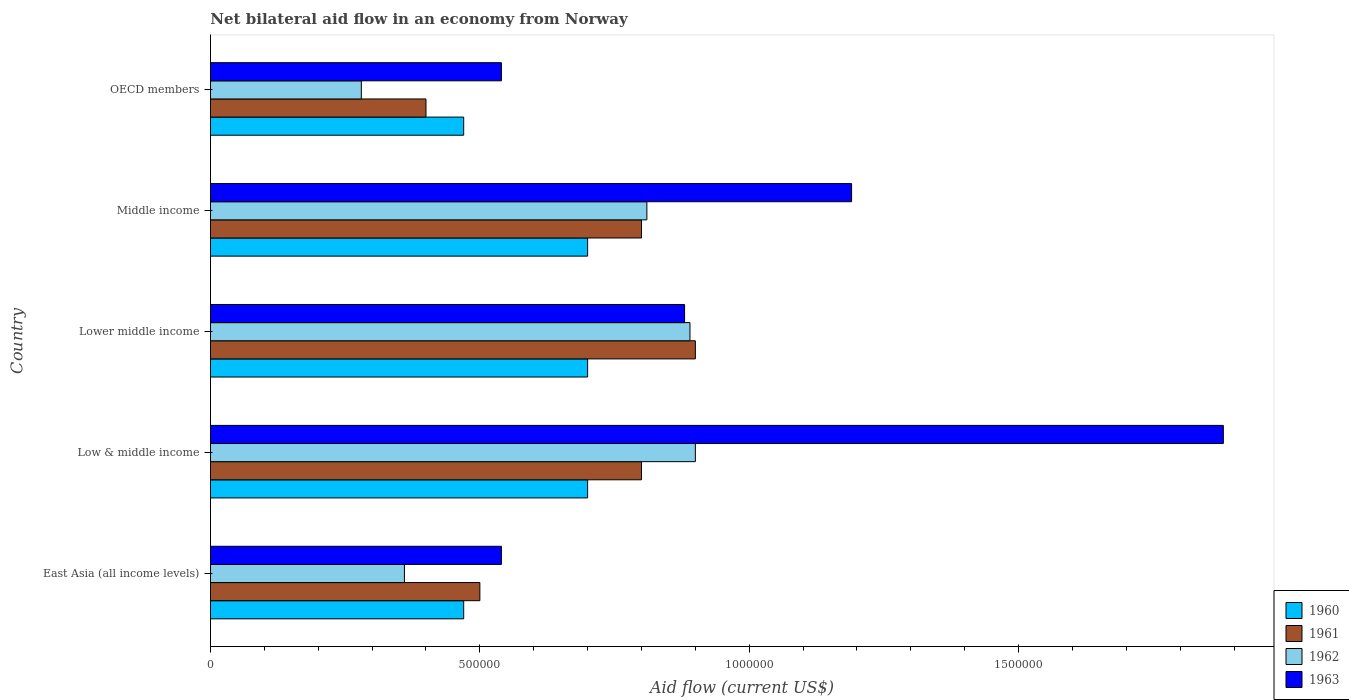How many different coloured bars are there?
Provide a short and direct response. 4. How many groups of bars are there?
Ensure brevity in your answer.  5. Are the number of bars on each tick of the Y-axis equal?
Your response must be concise. Yes. How many bars are there on the 3rd tick from the bottom?
Your answer should be compact. 4. What is the label of the 5th group of bars from the top?
Your response must be concise. East Asia (all income levels). What is the net bilateral aid flow in 1960 in Lower middle income?
Provide a short and direct response. 7.00e+05. Across all countries, what is the minimum net bilateral aid flow in 1962?
Keep it short and to the point. 2.80e+05. In which country was the net bilateral aid flow in 1961 maximum?
Give a very brief answer. Lower middle income. In which country was the net bilateral aid flow in 1963 minimum?
Offer a very short reply. East Asia (all income levels). What is the total net bilateral aid flow in 1960 in the graph?
Offer a terse response. 3.04e+06. What is the difference between the net bilateral aid flow in 1963 in Low & middle income and that in Middle income?
Your answer should be compact. 6.90e+05. What is the difference between the net bilateral aid flow in 1963 in OECD members and the net bilateral aid flow in 1960 in Lower middle income?
Keep it short and to the point. -1.60e+05. What is the average net bilateral aid flow in 1960 per country?
Give a very brief answer. 6.08e+05. What is the difference between the highest and the lowest net bilateral aid flow in 1962?
Your answer should be very brief. 6.20e+05. Is the sum of the net bilateral aid flow in 1962 in Middle income and OECD members greater than the maximum net bilateral aid flow in 1963 across all countries?
Provide a short and direct response. No. What does the 1st bar from the top in Lower middle income represents?
Offer a very short reply. 1963. What does the 3rd bar from the bottom in OECD members represents?
Make the answer very short. 1962. How many bars are there?
Your response must be concise. 20. Are all the bars in the graph horizontal?
Provide a succinct answer. Yes. Are the values on the major ticks of X-axis written in scientific E-notation?
Offer a terse response. No. Does the graph contain any zero values?
Keep it short and to the point. No. Does the graph contain grids?
Ensure brevity in your answer.  No. Where does the legend appear in the graph?
Your answer should be compact. Bottom right. How many legend labels are there?
Your answer should be compact. 4. How are the legend labels stacked?
Make the answer very short. Vertical. What is the title of the graph?
Your response must be concise. Net bilateral aid flow in an economy from Norway. Does "1962" appear as one of the legend labels in the graph?
Ensure brevity in your answer.  Yes. What is the Aid flow (current US$) in 1963 in East Asia (all income levels)?
Keep it short and to the point. 5.40e+05. What is the Aid flow (current US$) of 1960 in Low & middle income?
Offer a terse response. 7.00e+05. What is the Aid flow (current US$) in 1961 in Low & middle income?
Your response must be concise. 8.00e+05. What is the Aid flow (current US$) in 1963 in Low & middle income?
Provide a short and direct response. 1.88e+06. What is the Aid flow (current US$) of 1960 in Lower middle income?
Provide a succinct answer. 7.00e+05. What is the Aid flow (current US$) in 1962 in Lower middle income?
Offer a terse response. 8.90e+05. What is the Aid flow (current US$) of 1963 in Lower middle income?
Provide a succinct answer. 8.80e+05. What is the Aid flow (current US$) in 1962 in Middle income?
Your answer should be compact. 8.10e+05. What is the Aid flow (current US$) in 1963 in Middle income?
Offer a very short reply. 1.19e+06. What is the Aid flow (current US$) in 1961 in OECD members?
Make the answer very short. 4.00e+05. What is the Aid flow (current US$) of 1963 in OECD members?
Your response must be concise. 5.40e+05. Across all countries, what is the maximum Aid flow (current US$) in 1961?
Offer a terse response. 9.00e+05. Across all countries, what is the maximum Aid flow (current US$) in 1963?
Your answer should be very brief. 1.88e+06. Across all countries, what is the minimum Aid flow (current US$) in 1960?
Your answer should be compact. 4.70e+05. Across all countries, what is the minimum Aid flow (current US$) of 1962?
Offer a very short reply. 2.80e+05. Across all countries, what is the minimum Aid flow (current US$) of 1963?
Your answer should be compact. 5.40e+05. What is the total Aid flow (current US$) of 1960 in the graph?
Give a very brief answer. 3.04e+06. What is the total Aid flow (current US$) of 1961 in the graph?
Your response must be concise. 3.40e+06. What is the total Aid flow (current US$) of 1962 in the graph?
Keep it short and to the point. 3.24e+06. What is the total Aid flow (current US$) in 1963 in the graph?
Provide a short and direct response. 5.03e+06. What is the difference between the Aid flow (current US$) in 1960 in East Asia (all income levels) and that in Low & middle income?
Your answer should be very brief. -2.30e+05. What is the difference between the Aid flow (current US$) of 1962 in East Asia (all income levels) and that in Low & middle income?
Offer a terse response. -5.40e+05. What is the difference between the Aid flow (current US$) of 1963 in East Asia (all income levels) and that in Low & middle income?
Offer a terse response. -1.34e+06. What is the difference between the Aid flow (current US$) of 1960 in East Asia (all income levels) and that in Lower middle income?
Ensure brevity in your answer.  -2.30e+05. What is the difference between the Aid flow (current US$) of 1961 in East Asia (all income levels) and that in Lower middle income?
Keep it short and to the point. -4.00e+05. What is the difference between the Aid flow (current US$) in 1962 in East Asia (all income levels) and that in Lower middle income?
Give a very brief answer. -5.30e+05. What is the difference between the Aid flow (current US$) of 1961 in East Asia (all income levels) and that in Middle income?
Your answer should be very brief. -3.00e+05. What is the difference between the Aid flow (current US$) in 1962 in East Asia (all income levels) and that in Middle income?
Your answer should be very brief. -4.50e+05. What is the difference between the Aid flow (current US$) of 1963 in East Asia (all income levels) and that in Middle income?
Your answer should be very brief. -6.50e+05. What is the difference between the Aid flow (current US$) of 1960 in East Asia (all income levels) and that in OECD members?
Give a very brief answer. 0. What is the difference between the Aid flow (current US$) of 1963 in East Asia (all income levels) and that in OECD members?
Provide a short and direct response. 0. What is the difference between the Aid flow (current US$) in 1963 in Low & middle income and that in Lower middle income?
Offer a terse response. 1.00e+06. What is the difference between the Aid flow (current US$) in 1960 in Low & middle income and that in Middle income?
Ensure brevity in your answer.  0. What is the difference between the Aid flow (current US$) of 1961 in Low & middle income and that in Middle income?
Offer a very short reply. 0. What is the difference between the Aid flow (current US$) in 1962 in Low & middle income and that in Middle income?
Ensure brevity in your answer.  9.00e+04. What is the difference between the Aid flow (current US$) in 1963 in Low & middle income and that in Middle income?
Ensure brevity in your answer.  6.90e+05. What is the difference between the Aid flow (current US$) in 1960 in Low & middle income and that in OECD members?
Offer a terse response. 2.30e+05. What is the difference between the Aid flow (current US$) of 1961 in Low & middle income and that in OECD members?
Your response must be concise. 4.00e+05. What is the difference between the Aid flow (current US$) of 1962 in Low & middle income and that in OECD members?
Make the answer very short. 6.20e+05. What is the difference between the Aid flow (current US$) in 1963 in Low & middle income and that in OECD members?
Offer a very short reply. 1.34e+06. What is the difference between the Aid flow (current US$) in 1960 in Lower middle income and that in Middle income?
Your answer should be compact. 0. What is the difference between the Aid flow (current US$) of 1962 in Lower middle income and that in Middle income?
Your response must be concise. 8.00e+04. What is the difference between the Aid flow (current US$) in 1963 in Lower middle income and that in Middle income?
Make the answer very short. -3.10e+05. What is the difference between the Aid flow (current US$) of 1960 in Middle income and that in OECD members?
Make the answer very short. 2.30e+05. What is the difference between the Aid flow (current US$) in 1962 in Middle income and that in OECD members?
Your answer should be compact. 5.30e+05. What is the difference between the Aid flow (current US$) in 1963 in Middle income and that in OECD members?
Offer a very short reply. 6.50e+05. What is the difference between the Aid flow (current US$) of 1960 in East Asia (all income levels) and the Aid flow (current US$) of 1961 in Low & middle income?
Your answer should be very brief. -3.30e+05. What is the difference between the Aid flow (current US$) of 1960 in East Asia (all income levels) and the Aid flow (current US$) of 1962 in Low & middle income?
Your answer should be very brief. -4.30e+05. What is the difference between the Aid flow (current US$) of 1960 in East Asia (all income levels) and the Aid flow (current US$) of 1963 in Low & middle income?
Keep it short and to the point. -1.41e+06. What is the difference between the Aid flow (current US$) in 1961 in East Asia (all income levels) and the Aid flow (current US$) in 1962 in Low & middle income?
Keep it short and to the point. -4.00e+05. What is the difference between the Aid flow (current US$) in 1961 in East Asia (all income levels) and the Aid flow (current US$) in 1963 in Low & middle income?
Provide a succinct answer. -1.38e+06. What is the difference between the Aid flow (current US$) in 1962 in East Asia (all income levels) and the Aid flow (current US$) in 1963 in Low & middle income?
Give a very brief answer. -1.52e+06. What is the difference between the Aid flow (current US$) of 1960 in East Asia (all income levels) and the Aid flow (current US$) of 1961 in Lower middle income?
Give a very brief answer. -4.30e+05. What is the difference between the Aid flow (current US$) in 1960 in East Asia (all income levels) and the Aid flow (current US$) in 1962 in Lower middle income?
Ensure brevity in your answer.  -4.20e+05. What is the difference between the Aid flow (current US$) of 1960 in East Asia (all income levels) and the Aid flow (current US$) of 1963 in Lower middle income?
Provide a succinct answer. -4.10e+05. What is the difference between the Aid flow (current US$) in 1961 in East Asia (all income levels) and the Aid flow (current US$) in 1962 in Lower middle income?
Provide a succinct answer. -3.90e+05. What is the difference between the Aid flow (current US$) of 1961 in East Asia (all income levels) and the Aid flow (current US$) of 1963 in Lower middle income?
Give a very brief answer. -3.80e+05. What is the difference between the Aid flow (current US$) of 1962 in East Asia (all income levels) and the Aid flow (current US$) of 1963 in Lower middle income?
Provide a short and direct response. -5.20e+05. What is the difference between the Aid flow (current US$) of 1960 in East Asia (all income levels) and the Aid flow (current US$) of 1961 in Middle income?
Provide a succinct answer. -3.30e+05. What is the difference between the Aid flow (current US$) of 1960 in East Asia (all income levels) and the Aid flow (current US$) of 1963 in Middle income?
Your answer should be very brief. -7.20e+05. What is the difference between the Aid flow (current US$) in 1961 in East Asia (all income levels) and the Aid flow (current US$) in 1962 in Middle income?
Your response must be concise. -3.10e+05. What is the difference between the Aid flow (current US$) of 1961 in East Asia (all income levels) and the Aid flow (current US$) of 1963 in Middle income?
Ensure brevity in your answer.  -6.90e+05. What is the difference between the Aid flow (current US$) in 1962 in East Asia (all income levels) and the Aid flow (current US$) in 1963 in Middle income?
Your answer should be compact. -8.30e+05. What is the difference between the Aid flow (current US$) of 1960 in East Asia (all income levels) and the Aid flow (current US$) of 1962 in OECD members?
Offer a terse response. 1.90e+05. What is the difference between the Aid flow (current US$) in 1960 in East Asia (all income levels) and the Aid flow (current US$) in 1963 in OECD members?
Offer a terse response. -7.00e+04. What is the difference between the Aid flow (current US$) in 1961 in Low & middle income and the Aid flow (current US$) in 1962 in Lower middle income?
Your answer should be compact. -9.00e+04. What is the difference between the Aid flow (current US$) of 1961 in Low & middle income and the Aid flow (current US$) of 1963 in Lower middle income?
Make the answer very short. -8.00e+04. What is the difference between the Aid flow (current US$) of 1960 in Low & middle income and the Aid flow (current US$) of 1961 in Middle income?
Your answer should be compact. -1.00e+05. What is the difference between the Aid flow (current US$) in 1960 in Low & middle income and the Aid flow (current US$) in 1962 in Middle income?
Your response must be concise. -1.10e+05. What is the difference between the Aid flow (current US$) in 1960 in Low & middle income and the Aid flow (current US$) in 1963 in Middle income?
Offer a very short reply. -4.90e+05. What is the difference between the Aid flow (current US$) of 1961 in Low & middle income and the Aid flow (current US$) of 1963 in Middle income?
Offer a terse response. -3.90e+05. What is the difference between the Aid flow (current US$) in 1962 in Low & middle income and the Aid flow (current US$) in 1963 in Middle income?
Offer a terse response. -2.90e+05. What is the difference between the Aid flow (current US$) in 1960 in Low & middle income and the Aid flow (current US$) in 1962 in OECD members?
Provide a short and direct response. 4.20e+05. What is the difference between the Aid flow (current US$) of 1960 in Low & middle income and the Aid flow (current US$) of 1963 in OECD members?
Keep it short and to the point. 1.60e+05. What is the difference between the Aid flow (current US$) in 1961 in Low & middle income and the Aid flow (current US$) in 1962 in OECD members?
Give a very brief answer. 5.20e+05. What is the difference between the Aid flow (current US$) of 1962 in Low & middle income and the Aid flow (current US$) of 1963 in OECD members?
Keep it short and to the point. 3.60e+05. What is the difference between the Aid flow (current US$) in 1960 in Lower middle income and the Aid flow (current US$) in 1961 in Middle income?
Your answer should be very brief. -1.00e+05. What is the difference between the Aid flow (current US$) of 1960 in Lower middle income and the Aid flow (current US$) of 1962 in Middle income?
Your answer should be compact. -1.10e+05. What is the difference between the Aid flow (current US$) in 1960 in Lower middle income and the Aid flow (current US$) in 1963 in Middle income?
Give a very brief answer. -4.90e+05. What is the difference between the Aid flow (current US$) in 1961 in Lower middle income and the Aid flow (current US$) in 1963 in Middle income?
Your response must be concise. -2.90e+05. What is the difference between the Aid flow (current US$) of 1960 in Lower middle income and the Aid flow (current US$) of 1961 in OECD members?
Offer a terse response. 3.00e+05. What is the difference between the Aid flow (current US$) of 1960 in Lower middle income and the Aid flow (current US$) of 1962 in OECD members?
Offer a very short reply. 4.20e+05. What is the difference between the Aid flow (current US$) of 1961 in Lower middle income and the Aid flow (current US$) of 1962 in OECD members?
Your response must be concise. 6.20e+05. What is the difference between the Aid flow (current US$) in 1962 in Lower middle income and the Aid flow (current US$) in 1963 in OECD members?
Ensure brevity in your answer.  3.50e+05. What is the difference between the Aid flow (current US$) of 1960 in Middle income and the Aid flow (current US$) of 1962 in OECD members?
Offer a terse response. 4.20e+05. What is the difference between the Aid flow (current US$) in 1960 in Middle income and the Aid flow (current US$) in 1963 in OECD members?
Your answer should be very brief. 1.60e+05. What is the difference between the Aid flow (current US$) in 1961 in Middle income and the Aid flow (current US$) in 1962 in OECD members?
Provide a short and direct response. 5.20e+05. What is the difference between the Aid flow (current US$) in 1962 in Middle income and the Aid flow (current US$) in 1963 in OECD members?
Give a very brief answer. 2.70e+05. What is the average Aid flow (current US$) in 1960 per country?
Make the answer very short. 6.08e+05. What is the average Aid flow (current US$) of 1961 per country?
Ensure brevity in your answer.  6.80e+05. What is the average Aid flow (current US$) in 1962 per country?
Make the answer very short. 6.48e+05. What is the average Aid flow (current US$) of 1963 per country?
Your response must be concise. 1.01e+06. What is the difference between the Aid flow (current US$) of 1960 and Aid flow (current US$) of 1961 in East Asia (all income levels)?
Offer a very short reply. -3.00e+04. What is the difference between the Aid flow (current US$) in 1960 and Aid flow (current US$) in 1962 in East Asia (all income levels)?
Offer a terse response. 1.10e+05. What is the difference between the Aid flow (current US$) in 1960 and Aid flow (current US$) in 1963 in East Asia (all income levels)?
Give a very brief answer. -7.00e+04. What is the difference between the Aid flow (current US$) in 1960 and Aid flow (current US$) in 1963 in Low & middle income?
Provide a succinct answer. -1.18e+06. What is the difference between the Aid flow (current US$) of 1961 and Aid flow (current US$) of 1962 in Low & middle income?
Your response must be concise. -1.00e+05. What is the difference between the Aid flow (current US$) of 1961 and Aid flow (current US$) of 1963 in Low & middle income?
Give a very brief answer. -1.08e+06. What is the difference between the Aid flow (current US$) of 1962 and Aid flow (current US$) of 1963 in Low & middle income?
Your response must be concise. -9.80e+05. What is the difference between the Aid flow (current US$) of 1960 and Aid flow (current US$) of 1962 in Lower middle income?
Provide a short and direct response. -1.90e+05. What is the difference between the Aid flow (current US$) in 1961 and Aid flow (current US$) in 1963 in Lower middle income?
Ensure brevity in your answer.  2.00e+04. What is the difference between the Aid flow (current US$) of 1960 and Aid flow (current US$) of 1961 in Middle income?
Your answer should be compact. -1.00e+05. What is the difference between the Aid flow (current US$) in 1960 and Aid flow (current US$) in 1962 in Middle income?
Your answer should be very brief. -1.10e+05. What is the difference between the Aid flow (current US$) of 1960 and Aid flow (current US$) of 1963 in Middle income?
Provide a succinct answer. -4.90e+05. What is the difference between the Aid flow (current US$) of 1961 and Aid flow (current US$) of 1963 in Middle income?
Keep it short and to the point. -3.90e+05. What is the difference between the Aid flow (current US$) in 1962 and Aid flow (current US$) in 1963 in Middle income?
Ensure brevity in your answer.  -3.80e+05. What is the difference between the Aid flow (current US$) of 1960 and Aid flow (current US$) of 1961 in OECD members?
Make the answer very short. 7.00e+04. What is the difference between the Aid flow (current US$) in 1961 and Aid flow (current US$) in 1962 in OECD members?
Make the answer very short. 1.20e+05. What is the difference between the Aid flow (current US$) in 1961 and Aid flow (current US$) in 1963 in OECD members?
Your answer should be compact. -1.40e+05. What is the ratio of the Aid flow (current US$) in 1960 in East Asia (all income levels) to that in Low & middle income?
Provide a short and direct response. 0.67. What is the ratio of the Aid flow (current US$) of 1963 in East Asia (all income levels) to that in Low & middle income?
Provide a short and direct response. 0.29. What is the ratio of the Aid flow (current US$) of 1960 in East Asia (all income levels) to that in Lower middle income?
Your answer should be very brief. 0.67. What is the ratio of the Aid flow (current US$) in 1961 in East Asia (all income levels) to that in Lower middle income?
Offer a very short reply. 0.56. What is the ratio of the Aid flow (current US$) of 1962 in East Asia (all income levels) to that in Lower middle income?
Your response must be concise. 0.4. What is the ratio of the Aid flow (current US$) of 1963 in East Asia (all income levels) to that in Lower middle income?
Provide a succinct answer. 0.61. What is the ratio of the Aid flow (current US$) of 1960 in East Asia (all income levels) to that in Middle income?
Ensure brevity in your answer.  0.67. What is the ratio of the Aid flow (current US$) of 1962 in East Asia (all income levels) to that in Middle income?
Make the answer very short. 0.44. What is the ratio of the Aid flow (current US$) of 1963 in East Asia (all income levels) to that in Middle income?
Offer a very short reply. 0.45. What is the ratio of the Aid flow (current US$) of 1963 in East Asia (all income levels) to that in OECD members?
Provide a succinct answer. 1. What is the ratio of the Aid flow (current US$) of 1961 in Low & middle income to that in Lower middle income?
Keep it short and to the point. 0.89. What is the ratio of the Aid flow (current US$) in 1962 in Low & middle income to that in Lower middle income?
Your answer should be very brief. 1.01. What is the ratio of the Aid flow (current US$) of 1963 in Low & middle income to that in Lower middle income?
Offer a terse response. 2.14. What is the ratio of the Aid flow (current US$) of 1960 in Low & middle income to that in Middle income?
Give a very brief answer. 1. What is the ratio of the Aid flow (current US$) of 1961 in Low & middle income to that in Middle income?
Your answer should be compact. 1. What is the ratio of the Aid flow (current US$) of 1963 in Low & middle income to that in Middle income?
Offer a terse response. 1.58. What is the ratio of the Aid flow (current US$) of 1960 in Low & middle income to that in OECD members?
Make the answer very short. 1.49. What is the ratio of the Aid flow (current US$) of 1962 in Low & middle income to that in OECD members?
Your answer should be very brief. 3.21. What is the ratio of the Aid flow (current US$) of 1963 in Low & middle income to that in OECD members?
Offer a very short reply. 3.48. What is the ratio of the Aid flow (current US$) in 1961 in Lower middle income to that in Middle income?
Provide a succinct answer. 1.12. What is the ratio of the Aid flow (current US$) in 1962 in Lower middle income to that in Middle income?
Offer a very short reply. 1.1. What is the ratio of the Aid flow (current US$) in 1963 in Lower middle income to that in Middle income?
Offer a very short reply. 0.74. What is the ratio of the Aid flow (current US$) of 1960 in Lower middle income to that in OECD members?
Provide a short and direct response. 1.49. What is the ratio of the Aid flow (current US$) of 1961 in Lower middle income to that in OECD members?
Offer a terse response. 2.25. What is the ratio of the Aid flow (current US$) of 1962 in Lower middle income to that in OECD members?
Your answer should be compact. 3.18. What is the ratio of the Aid flow (current US$) of 1963 in Lower middle income to that in OECD members?
Offer a very short reply. 1.63. What is the ratio of the Aid flow (current US$) of 1960 in Middle income to that in OECD members?
Provide a succinct answer. 1.49. What is the ratio of the Aid flow (current US$) in 1962 in Middle income to that in OECD members?
Provide a short and direct response. 2.89. What is the ratio of the Aid flow (current US$) in 1963 in Middle income to that in OECD members?
Your answer should be very brief. 2.2. What is the difference between the highest and the second highest Aid flow (current US$) in 1960?
Offer a very short reply. 0. What is the difference between the highest and the second highest Aid flow (current US$) in 1963?
Provide a short and direct response. 6.90e+05. What is the difference between the highest and the lowest Aid flow (current US$) of 1962?
Your answer should be very brief. 6.20e+05. What is the difference between the highest and the lowest Aid flow (current US$) in 1963?
Your answer should be compact. 1.34e+06. 